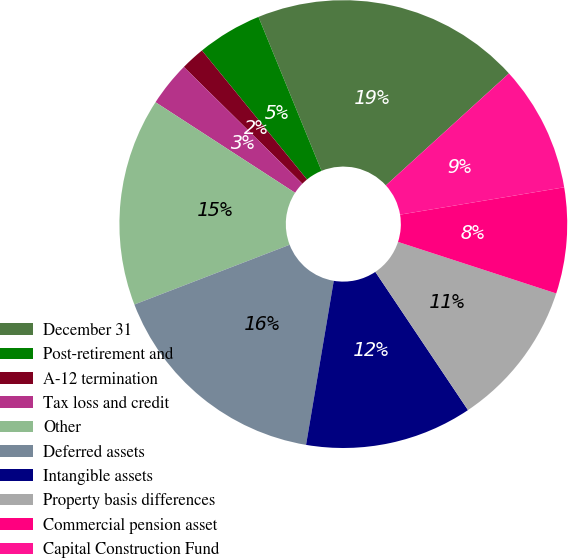Convert chart. <chart><loc_0><loc_0><loc_500><loc_500><pie_chart><fcel>December 31<fcel>Post-retirement and<fcel>A-12 termination<fcel>Tax loss and credit<fcel>Other<fcel>Deferred assets<fcel>Intangible assets<fcel>Property basis differences<fcel>Commercial pension asset<fcel>Capital Construction Fund<nl><fcel>19.44%<fcel>4.69%<fcel>1.74%<fcel>3.22%<fcel>15.01%<fcel>16.49%<fcel>12.06%<fcel>10.59%<fcel>7.64%<fcel>9.12%<nl></chart> 